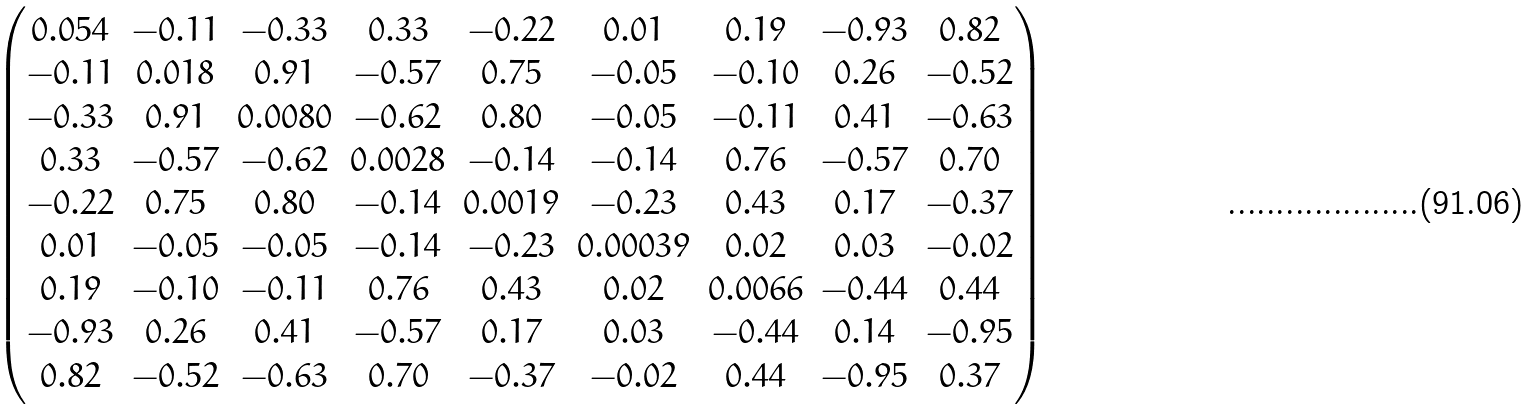<formula> <loc_0><loc_0><loc_500><loc_500>\begin{pmatrix} 0 . 0 5 4 & - 0 . 1 1 & - 0 . 3 3 & 0 . 3 3 & - 0 . 2 2 & 0 . 0 1 & 0 . 1 9 & - 0 . 9 3 & 0 . 8 2 \\ - 0 . 1 1 & 0 . 0 1 8 & 0 . 9 1 & - 0 . 5 7 & 0 . 7 5 & - 0 . 0 5 & - 0 . 1 0 & 0 . 2 6 & - 0 . 5 2 \\ - 0 . 3 3 & 0 . 9 1 & 0 . 0 0 8 0 & - 0 . 6 2 & 0 . 8 0 & - 0 . 0 5 & - 0 . 1 1 & 0 . 4 1 & - 0 . 6 3 \\ 0 . 3 3 & - 0 . 5 7 & - 0 . 6 2 & 0 . 0 0 2 8 & - 0 . 1 4 & - 0 . 1 4 & 0 . 7 6 & - 0 . 5 7 & 0 . 7 0 \\ - 0 . 2 2 & 0 . 7 5 & 0 . 8 0 & - 0 . 1 4 & 0 . 0 0 1 9 & - 0 . 2 3 & 0 . 4 3 & 0 . 1 7 & - 0 . 3 7 \\ 0 . 0 1 & - 0 . 0 5 & - 0 . 0 5 & - 0 . 1 4 & - 0 . 2 3 & 0 . 0 0 0 3 9 & 0 . 0 2 & 0 . 0 3 & - 0 . 0 2 \\ 0 . 1 9 & - 0 . 1 0 & - 0 . 1 1 & 0 . 7 6 & 0 . 4 3 & 0 . 0 2 & 0 . 0 0 6 6 & - 0 . 4 4 & 0 . 4 4 \\ - 0 . 9 3 & 0 . 2 6 & 0 . 4 1 & - 0 . 5 7 & 0 . 1 7 & 0 . 0 3 & - 0 . 4 4 & 0 . 1 4 & - 0 . 9 5 \\ 0 . 8 2 & - 0 . 5 2 & - 0 . 6 3 & 0 . 7 0 & - 0 . 3 7 & - 0 . 0 2 & 0 . 4 4 & - 0 . 9 5 & 0 . 3 7 \end{pmatrix}</formula> 